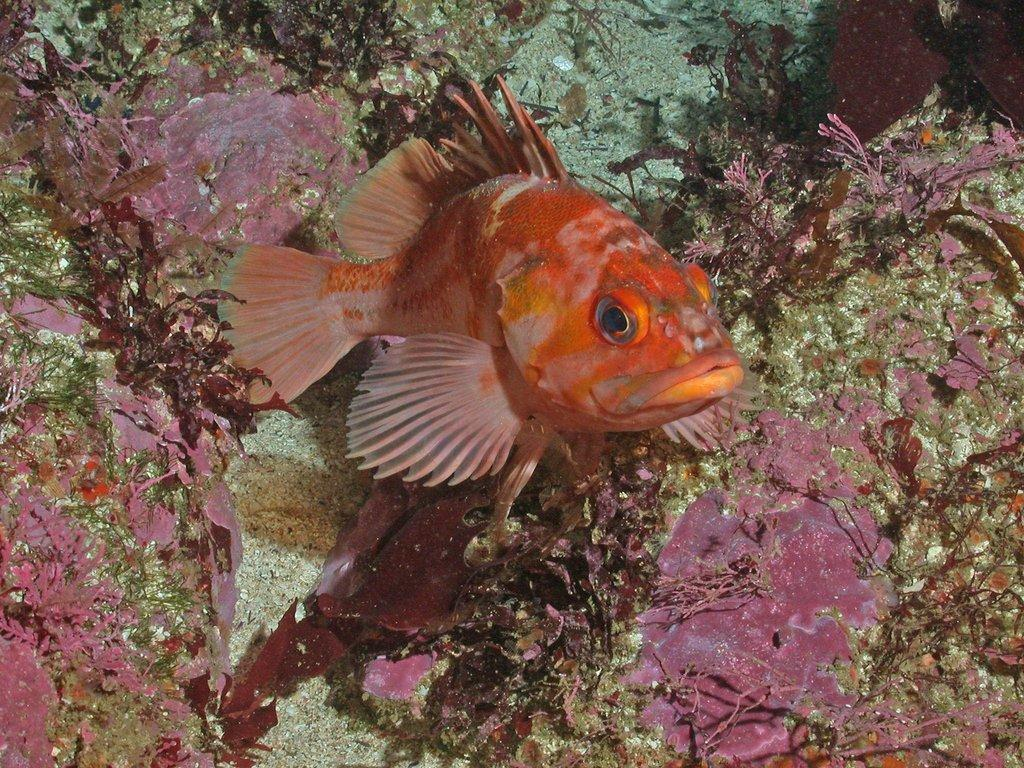What is the main subject of the image? The main subject of the image is a small fish. Where is the small fish located in the image? The small fish is in the middle of the image. What can be seen in the background of the image? There are aquatic plants in the background of the image. What type of railway can be seen in the image? There is no railway present in the image; it features a small fish in the middle and aquatic plants in the background. 